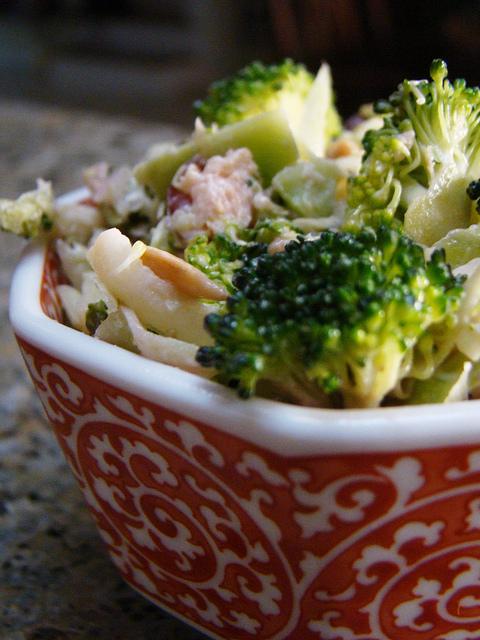What kind of pattern is on the bowl?
Be succinct. Floral. What color is the bowl?
Answer briefly. Red and white. Is there broccoli in the dish?
Write a very short answer. Yes. What kind of food is this?
Answer briefly. Broccoli. 